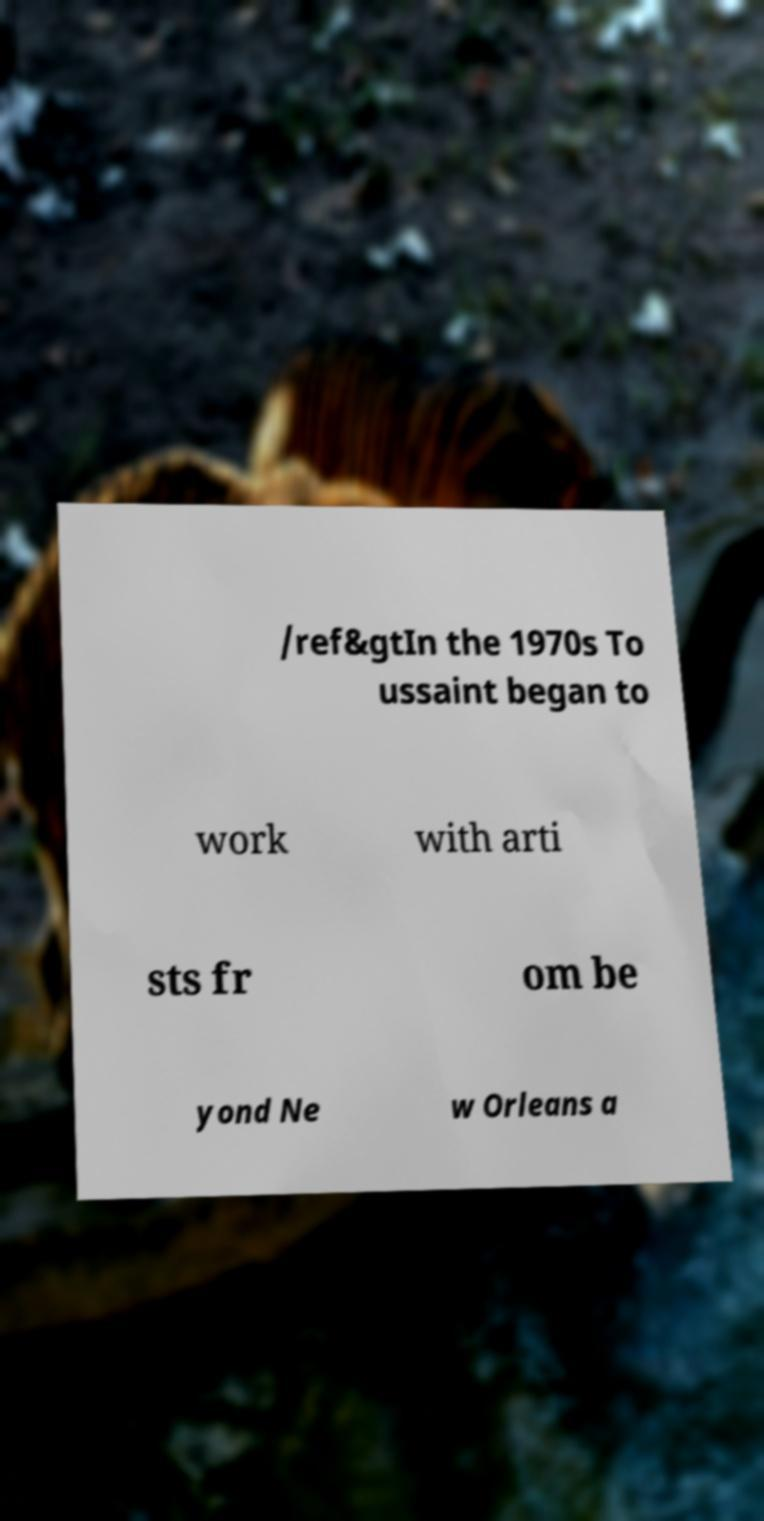Please read and relay the text visible in this image. What does it say? /ref&gtIn the 1970s To ussaint began to work with arti sts fr om be yond Ne w Orleans a 